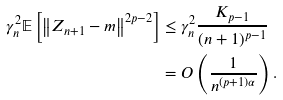Convert formula to latex. <formula><loc_0><loc_0><loc_500><loc_500>\gamma _ { n } ^ { 2 } \mathbb { E } \left [ \left \| Z _ { n + 1 } - m \right \| ^ { 2 p - 2 } \right ] & \leq \gamma _ { n } ^ { 2 } \frac { K _ { p - 1 } } { ( n + 1 ) ^ { p - 1 } } \\ & = O \left ( \frac { 1 } { n ^ { ( p + 1 ) \alpha } } \right ) .</formula> 